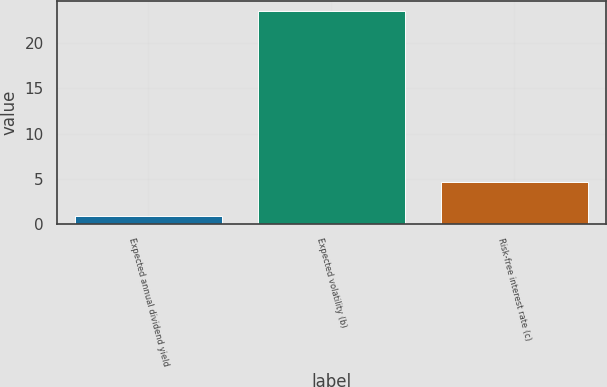Convert chart to OTSL. <chart><loc_0><loc_0><loc_500><loc_500><bar_chart><fcel>Expected annual dividend yield<fcel>Expected volatility (b)<fcel>Risk-free interest rate (c)<nl><fcel>0.92<fcel>23.5<fcel>4.61<nl></chart> 